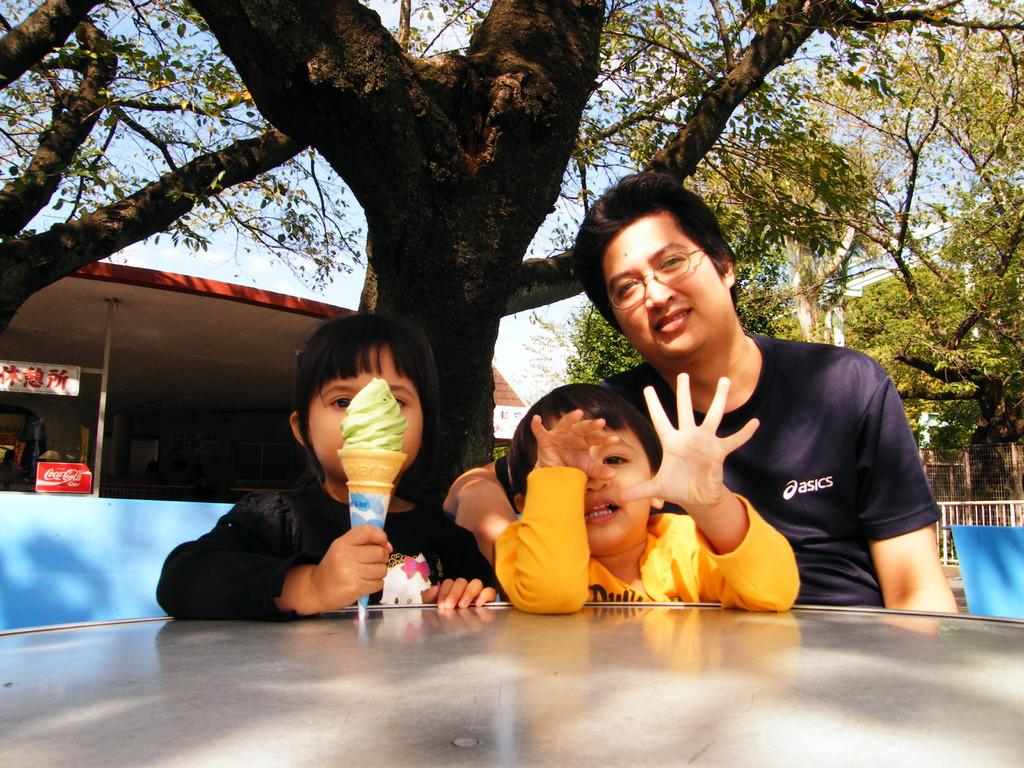How many people are in the image? There are three persons in the image. What are the persons doing in the image? The persons are sitting on chairs. What is in front of the persons? There is a table in front of the persons. What can be seen in the background of the image? There are trees and buildings in the background of the image. What is visible at the top of the image? The sky is visible at the top of the image. Can you tell me how many geese are depicted in the image? There are no geese present in the image. What type of experience does the person sitting on the left chair have? The image does not provide any information about the experiences of the persons in the image. 